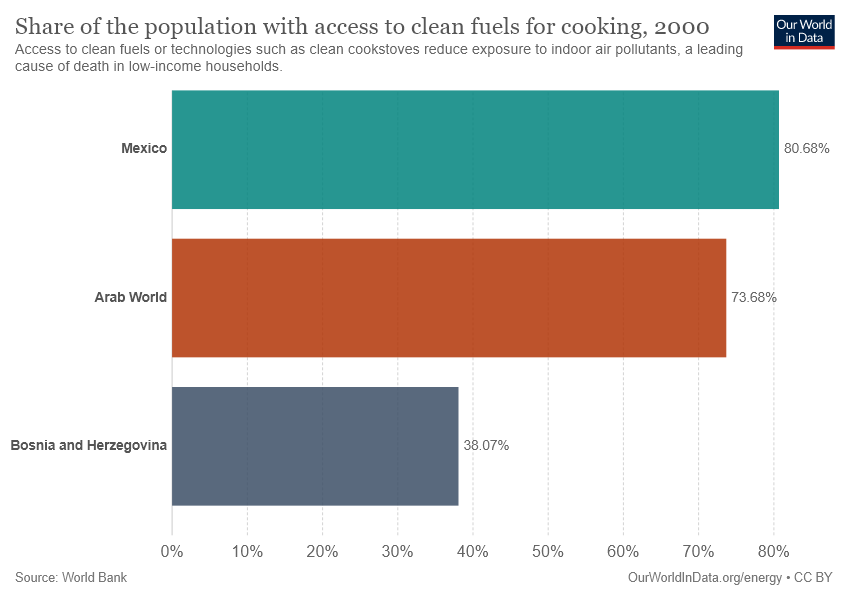Mention a couple of crucial points in this snapshot. There are three colors displayed in the chart. The difference in value between Mexico and the Arab World is 0.07. 